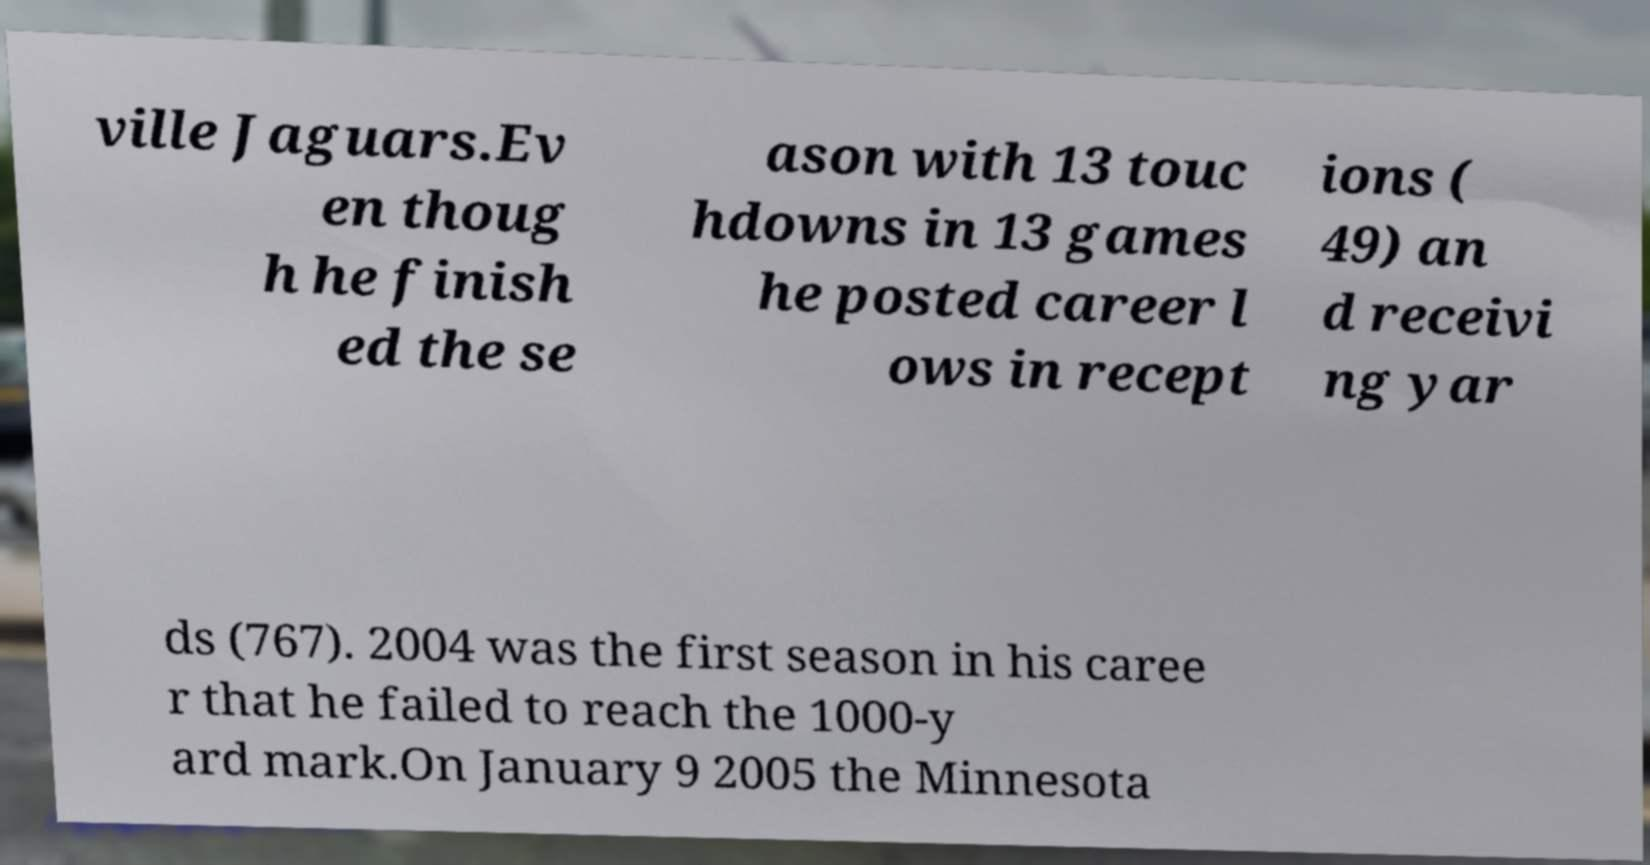Could you extract and type out the text from this image? ville Jaguars.Ev en thoug h he finish ed the se ason with 13 touc hdowns in 13 games he posted career l ows in recept ions ( 49) an d receivi ng yar ds (767). 2004 was the first season in his caree r that he failed to reach the 1000-y ard mark.On January 9 2005 the Minnesota 